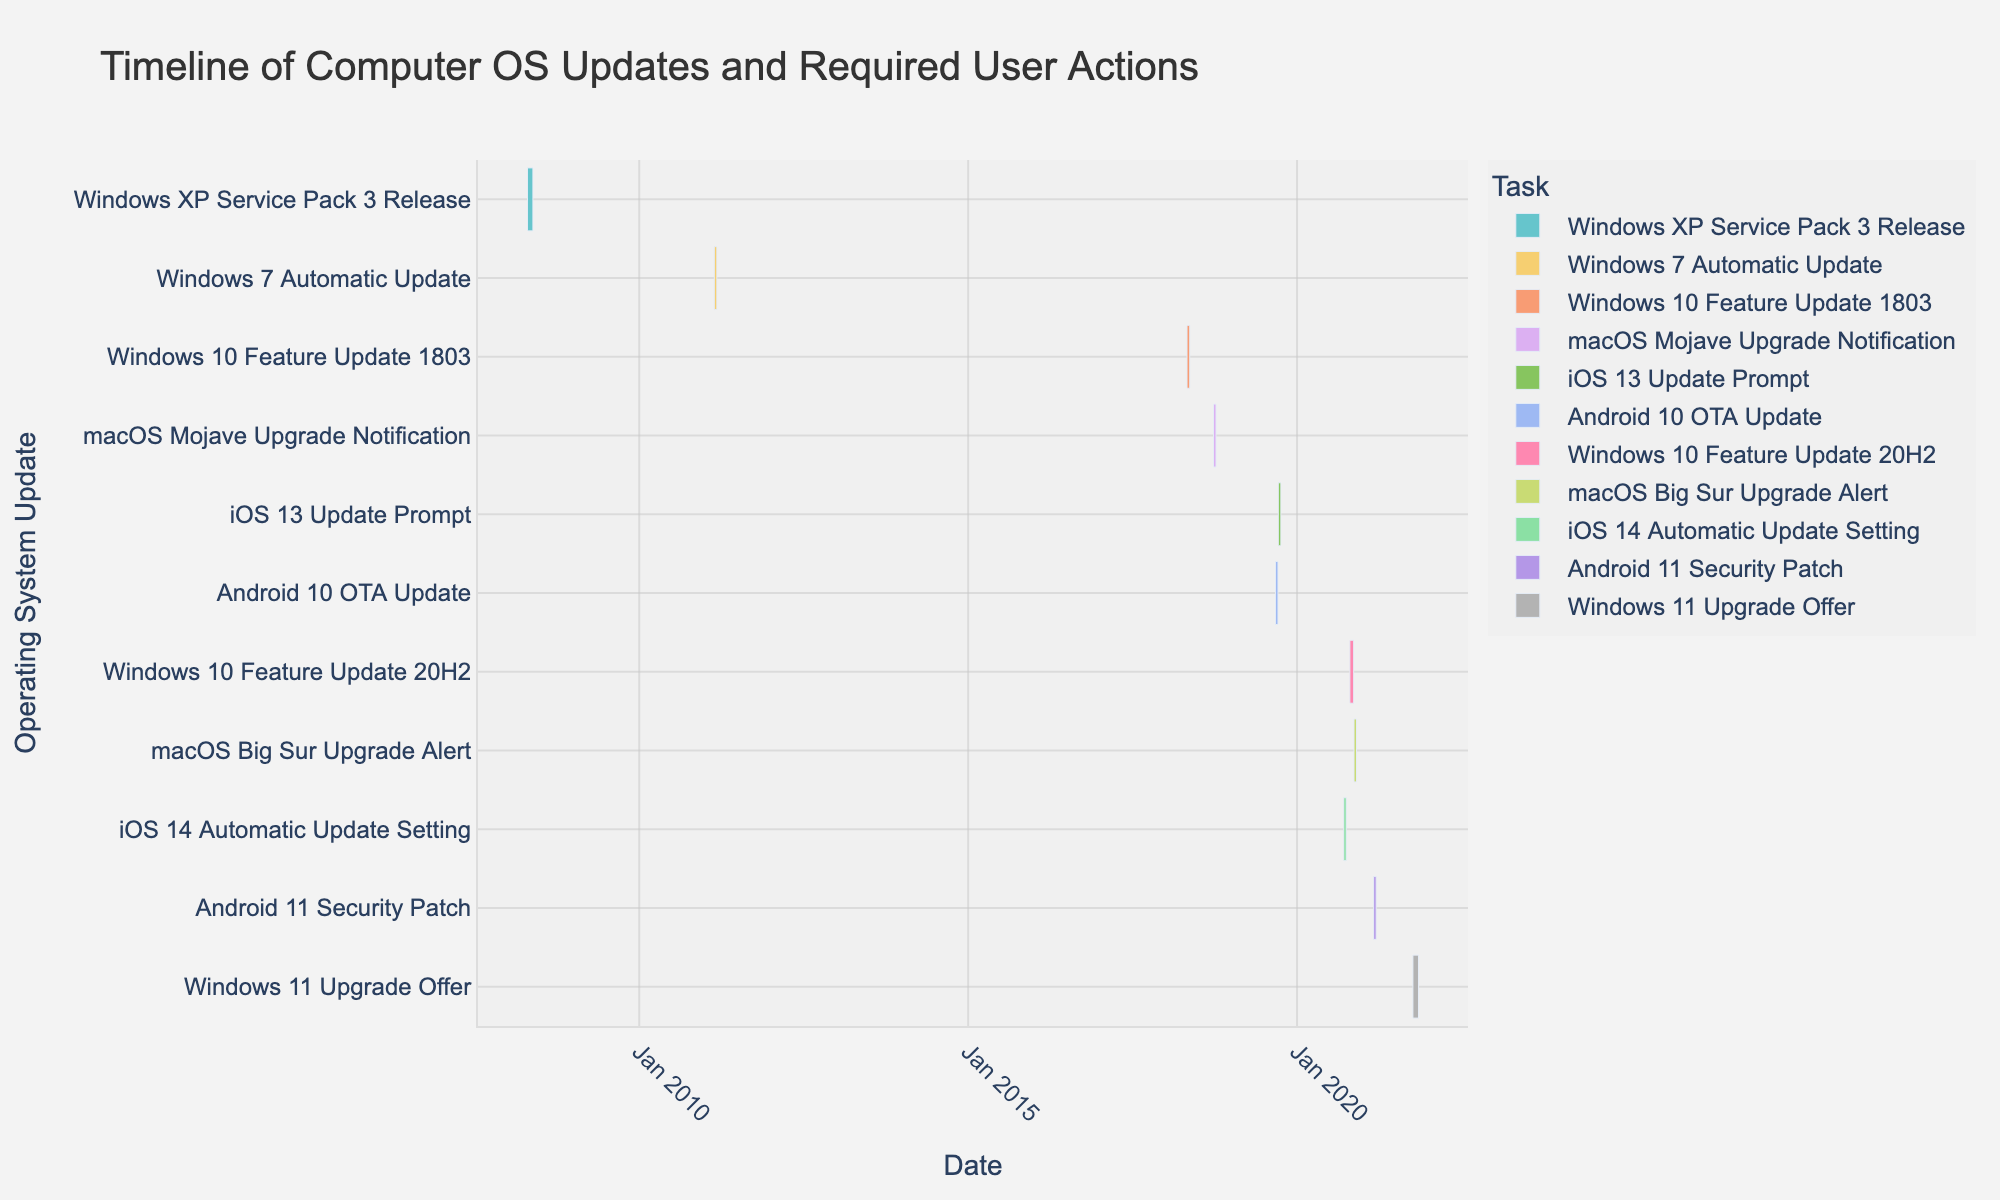what's the title of the figure? The title of the figure is usually displayed at the top and gives an overview of what the figure represents. In this case, the title should describe the figure's content related to computer OS updates.
Answer: Timeline of Computer OS Updates and Required User Actions How long did the Windows XP Service Pack 3 update take? To find the duration of the update, we need to look at the start and end dates of the task "Windows XP Service Pack 3 Release" and calculate the difference between the two dates. The task started on 2008-04-21 and ended on 2008-05-21, so the duration is 30 days.
Answer: 30 days Which update lasted longer, macOS Mojave Upgrade Notification or Windows 7 Automatic Update? We compare the durations of both updates. The macOS Mojave Upgrade Notification lasted from 2018-09-24 to 2018-10-08, which is 14 days. The Windows 7 Automatic Update lasted from 2011-02-22 to 2011-03-08, which is 14 days as well.
Answer: Both lasted the same duration How many updates occurred between January 2018 and December 2020? We identify the updates that started within the specified period. The updates within this timeframe are: Windows 10 Feature Update 1803 (2018-04-30), macOS Mojave Upgrade Notification (2018-09-24), iOS 13 Update Prompt (2019-09-19), Android 10 OTA Update (2019-09-03), Windows 10 Feature Update 20H2 (2020-10-20), macOS Big Sur Upgrade Alert (2020-11-12), and iOS 14 Automatic Update Setting (2020-09-16). In total, there are 7 updates.
Answer: 7 Which update had the shortest duration? The shortest duration can be found by comparing the lengths of all update tasks. The Android 10 OTA Update lasted from 2019-09-03 to 2019-09-17, and the duration is only 14 days, which appears to be the shortest among all listed updates.
Answer: Android 10 OTA Update Do more updates occur in autumn or spring? To determine this, we need to count the updates that started in autumn (September to November) and in spring (March to May). Updates in autumn: macOS Mojave Upgrade Notification (September 24), Android 10 OTA Update (September 3), iOS 14 Automatic Update Setting (September 16), macOS Big Sur Upgrade Alert (November 12), and Windows 11 Upgrade Offer (October 5). In spring: Windows 7 Automatic Update (February 22) and Windows 10 Feature Update 1803 (April 30). Autumn has 5 updates, and spring has 2 updates.
Answer: Autumn Which year had the most updates? By counting the number of updates for each year: 2008 (1), 2011 (1), 2018 (2), 2019 (2), 2020 (3), 2021 (2). The year with the most updates is 2020 with 3 updates.
Answer: 2020 